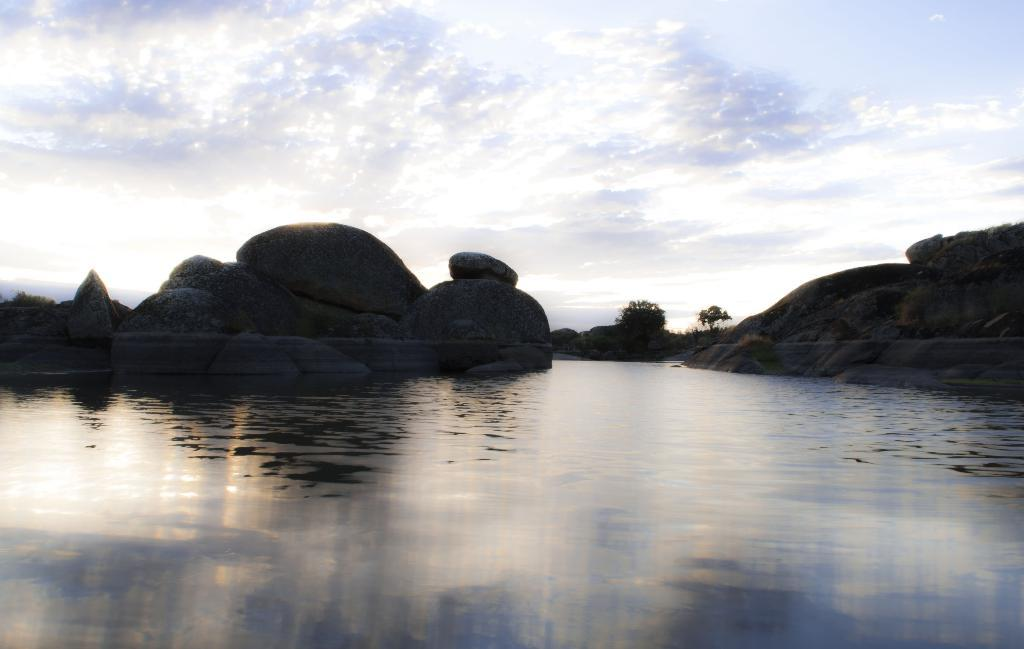What is the primary element in the picture? There is water in the picture. What other objects or features can be seen in the picture? There are rocks and trees in the picture. How would you describe the sky in the background? The sky in the background is cloudy. What type of book can be seen floating in the water in the picture? There is no book present in the picture; it only features water, rocks, trees, and a cloudy sky. 